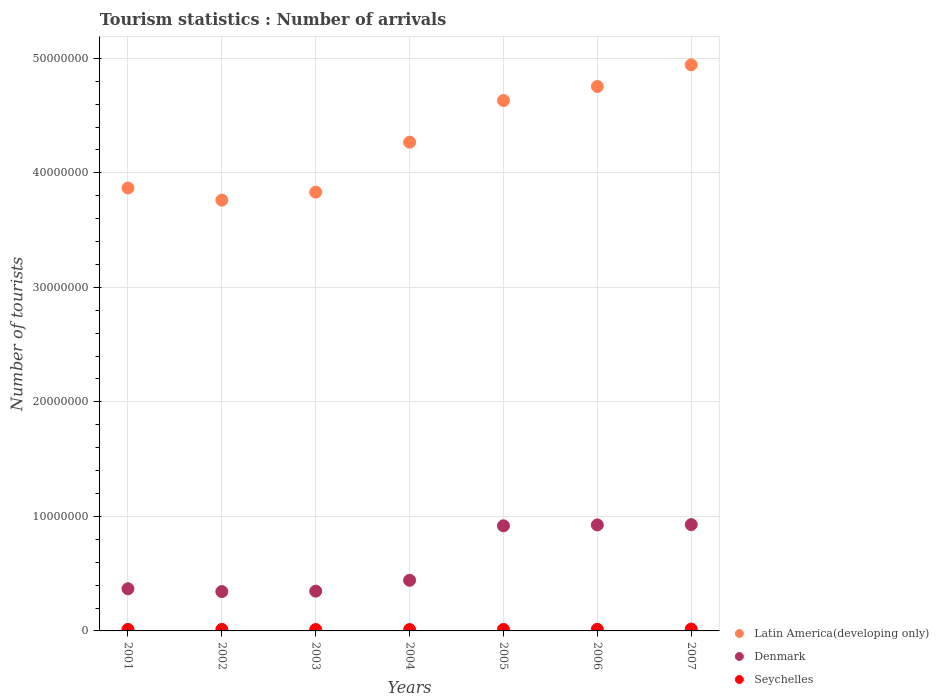How many different coloured dotlines are there?
Your answer should be compact. 3. What is the number of tourist arrivals in Seychelles in 2002?
Give a very brief answer. 1.32e+05. Across all years, what is the maximum number of tourist arrivals in Denmark?
Keep it short and to the point. 9.28e+06. Across all years, what is the minimum number of tourist arrivals in Latin America(developing only)?
Offer a terse response. 3.76e+07. In which year was the number of tourist arrivals in Seychelles maximum?
Offer a terse response. 2007. In which year was the number of tourist arrivals in Denmark minimum?
Keep it short and to the point. 2002. What is the total number of tourist arrivals in Denmark in the graph?
Give a very brief answer. 4.27e+07. What is the difference between the number of tourist arrivals in Latin America(developing only) in 2005 and that in 2007?
Offer a very short reply. -3.12e+06. What is the difference between the number of tourist arrivals in Seychelles in 2006 and the number of tourist arrivals in Latin America(developing only) in 2001?
Your response must be concise. -3.85e+07. What is the average number of tourist arrivals in Seychelles per year?
Offer a terse response. 1.34e+05. In the year 2002, what is the difference between the number of tourist arrivals in Latin America(developing only) and number of tourist arrivals in Denmark?
Your response must be concise. 3.42e+07. What is the ratio of the number of tourist arrivals in Denmark in 2001 to that in 2005?
Make the answer very short. 0.4. What is the difference between the highest and the second highest number of tourist arrivals in Latin America(developing only)?
Keep it short and to the point. 1.89e+06. What is the difference between the highest and the lowest number of tourist arrivals in Latin America(developing only)?
Provide a succinct answer. 1.18e+07. In how many years, is the number of tourist arrivals in Seychelles greater than the average number of tourist arrivals in Seychelles taken over all years?
Provide a succinct answer. 2. Is it the case that in every year, the sum of the number of tourist arrivals in Seychelles and number of tourist arrivals in Latin America(developing only)  is greater than the number of tourist arrivals in Denmark?
Your response must be concise. Yes. Is the number of tourist arrivals in Seychelles strictly less than the number of tourist arrivals in Latin America(developing only) over the years?
Offer a terse response. Yes. What is the title of the graph?
Ensure brevity in your answer.  Tourism statistics : Number of arrivals. What is the label or title of the X-axis?
Make the answer very short. Years. What is the label or title of the Y-axis?
Give a very brief answer. Number of tourists. What is the Number of tourists in Latin America(developing only) in 2001?
Offer a very short reply. 3.87e+07. What is the Number of tourists of Denmark in 2001?
Provide a succinct answer. 3.68e+06. What is the Number of tourists of Latin America(developing only) in 2002?
Offer a very short reply. 3.76e+07. What is the Number of tourists of Denmark in 2002?
Your answer should be very brief. 3.44e+06. What is the Number of tourists in Seychelles in 2002?
Your response must be concise. 1.32e+05. What is the Number of tourists in Latin America(developing only) in 2003?
Give a very brief answer. 3.83e+07. What is the Number of tourists of Denmark in 2003?
Offer a very short reply. 3.47e+06. What is the Number of tourists in Seychelles in 2003?
Your answer should be compact. 1.22e+05. What is the Number of tourists in Latin America(developing only) in 2004?
Offer a very short reply. 4.27e+07. What is the Number of tourists in Denmark in 2004?
Keep it short and to the point. 4.42e+06. What is the Number of tourists of Seychelles in 2004?
Your answer should be compact. 1.21e+05. What is the Number of tourists of Latin America(developing only) in 2005?
Your response must be concise. 4.63e+07. What is the Number of tourists in Denmark in 2005?
Ensure brevity in your answer.  9.18e+06. What is the Number of tourists of Seychelles in 2005?
Offer a terse response. 1.29e+05. What is the Number of tourists of Latin America(developing only) in 2006?
Provide a succinct answer. 4.75e+07. What is the Number of tourists in Denmark in 2006?
Offer a terse response. 9.26e+06. What is the Number of tourists in Seychelles in 2006?
Provide a succinct answer. 1.41e+05. What is the Number of tourists of Latin America(developing only) in 2007?
Your answer should be very brief. 4.94e+07. What is the Number of tourists in Denmark in 2007?
Your answer should be very brief. 9.28e+06. What is the Number of tourists in Seychelles in 2007?
Provide a short and direct response. 1.61e+05. Across all years, what is the maximum Number of tourists in Latin America(developing only)?
Your response must be concise. 4.94e+07. Across all years, what is the maximum Number of tourists in Denmark?
Offer a terse response. 9.28e+06. Across all years, what is the maximum Number of tourists of Seychelles?
Offer a very short reply. 1.61e+05. Across all years, what is the minimum Number of tourists in Latin America(developing only)?
Your answer should be very brief. 3.76e+07. Across all years, what is the minimum Number of tourists in Denmark?
Your response must be concise. 3.44e+06. Across all years, what is the minimum Number of tourists in Seychelles?
Ensure brevity in your answer.  1.21e+05. What is the total Number of tourists of Latin America(developing only) in the graph?
Make the answer very short. 3.01e+08. What is the total Number of tourists of Denmark in the graph?
Provide a short and direct response. 4.27e+07. What is the total Number of tourists in Seychelles in the graph?
Offer a terse response. 9.36e+05. What is the difference between the Number of tourists in Latin America(developing only) in 2001 and that in 2002?
Offer a terse response. 1.06e+06. What is the difference between the Number of tourists in Denmark in 2001 and that in 2002?
Your answer should be compact. 2.48e+05. What is the difference between the Number of tourists of Seychelles in 2001 and that in 2002?
Your response must be concise. -2000. What is the difference between the Number of tourists in Latin America(developing only) in 2001 and that in 2003?
Provide a succinct answer. 3.61e+05. What is the difference between the Number of tourists in Seychelles in 2001 and that in 2003?
Provide a succinct answer. 8000. What is the difference between the Number of tourists in Latin America(developing only) in 2001 and that in 2004?
Offer a terse response. -4.00e+06. What is the difference between the Number of tourists in Denmark in 2001 and that in 2004?
Your response must be concise. -7.37e+05. What is the difference between the Number of tourists of Seychelles in 2001 and that in 2004?
Keep it short and to the point. 9000. What is the difference between the Number of tourists of Latin America(developing only) in 2001 and that in 2005?
Offer a very short reply. -7.64e+06. What is the difference between the Number of tourists in Denmark in 2001 and that in 2005?
Provide a succinct answer. -5.49e+06. What is the difference between the Number of tourists of Latin America(developing only) in 2001 and that in 2006?
Offer a terse response. -8.86e+06. What is the difference between the Number of tourists in Denmark in 2001 and that in 2006?
Make the answer very short. -5.57e+06. What is the difference between the Number of tourists in Seychelles in 2001 and that in 2006?
Your answer should be very brief. -1.10e+04. What is the difference between the Number of tourists in Latin America(developing only) in 2001 and that in 2007?
Provide a succinct answer. -1.08e+07. What is the difference between the Number of tourists of Denmark in 2001 and that in 2007?
Give a very brief answer. -5.60e+06. What is the difference between the Number of tourists in Seychelles in 2001 and that in 2007?
Your answer should be compact. -3.10e+04. What is the difference between the Number of tourists in Latin America(developing only) in 2002 and that in 2003?
Provide a short and direct response. -7.00e+05. What is the difference between the Number of tourists of Denmark in 2002 and that in 2003?
Make the answer very short. -3.80e+04. What is the difference between the Number of tourists in Latin America(developing only) in 2002 and that in 2004?
Give a very brief answer. -5.06e+06. What is the difference between the Number of tourists in Denmark in 2002 and that in 2004?
Ensure brevity in your answer.  -9.85e+05. What is the difference between the Number of tourists of Seychelles in 2002 and that in 2004?
Your answer should be compact. 1.10e+04. What is the difference between the Number of tourists in Latin America(developing only) in 2002 and that in 2005?
Ensure brevity in your answer.  -8.70e+06. What is the difference between the Number of tourists in Denmark in 2002 and that in 2005?
Provide a short and direct response. -5.74e+06. What is the difference between the Number of tourists of Seychelles in 2002 and that in 2005?
Offer a very short reply. 3000. What is the difference between the Number of tourists of Latin America(developing only) in 2002 and that in 2006?
Your answer should be compact. -9.93e+06. What is the difference between the Number of tourists of Denmark in 2002 and that in 2006?
Offer a very short reply. -5.82e+06. What is the difference between the Number of tourists in Seychelles in 2002 and that in 2006?
Your answer should be very brief. -9000. What is the difference between the Number of tourists in Latin America(developing only) in 2002 and that in 2007?
Your response must be concise. -1.18e+07. What is the difference between the Number of tourists in Denmark in 2002 and that in 2007?
Ensure brevity in your answer.  -5.85e+06. What is the difference between the Number of tourists in Seychelles in 2002 and that in 2007?
Your answer should be compact. -2.90e+04. What is the difference between the Number of tourists in Latin America(developing only) in 2003 and that in 2004?
Your answer should be compact. -4.36e+06. What is the difference between the Number of tourists in Denmark in 2003 and that in 2004?
Provide a short and direct response. -9.47e+05. What is the difference between the Number of tourists in Latin America(developing only) in 2003 and that in 2005?
Your response must be concise. -8.00e+06. What is the difference between the Number of tourists of Denmark in 2003 and that in 2005?
Provide a succinct answer. -5.70e+06. What is the difference between the Number of tourists of Seychelles in 2003 and that in 2005?
Provide a succinct answer. -7000. What is the difference between the Number of tourists of Latin America(developing only) in 2003 and that in 2006?
Your answer should be compact. -9.23e+06. What is the difference between the Number of tourists in Denmark in 2003 and that in 2006?
Provide a short and direct response. -5.78e+06. What is the difference between the Number of tourists in Seychelles in 2003 and that in 2006?
Your response must be concise. -1.90e+04. What is the difference between the Number of tourists in Latin America(developing only) in 2003 and that in 2007?
Ensure brevity in your answer.  -1.11e+07. What is the difference between the Number of tourists of Denmark in 2003 and that in 2007?
Keep it short and to the point. -5.81e+06. What is the difference between the Number of tourists in Seychelles in 2003 and that in 2007?
Make the answer very short. -3.90e+04. What is the difference between the Number of tourists in Latin America(developing only) in 2004 and that in 2005?
Provide a short and direct response. -3.63e+06. What is the difference between the Number of tourists of Denmark in 2004 and that in 2005?
Provide a succinct answer. -4.76e+06. What is the difference between the Number of tourists in Seychelles in 2004 and that in 2005?
Offer a terse response. -8000. What is the difference between the Number of tourists in Latin America(developing only) in 2004 and that in 2006?
Offer a terse response. -4.86e+06. What is the difference between the Number of tourists in Denmark in 2004 and that in 2006?
Make the answer very short. -4.84e+06. What is the difference between the Number of tourists of Seychelles in 2004 and that in 2006?
Your answer should be compact. -2.00e+04. What is the difference between the Number of tourists of Latin America(developing only) in 2004 and that in 2007?
Offer a very short reply. -6.75e+06. What is the difference between the Number of tourists of Denmark in 2004 and that in 2007?
Make the answer very short. -4.86e+06. What is the difference between the Number of tourists in Latin America(developing only) in 2005 and that in 2006?
Your answer should be very brief. -1.23e+06. What is the difference between the Number of tourists in Denmark in 2005 and that in 2006?
Keep it short and to the point. -7.80e+04. What is the difference between the Number of tourists in Seychelles in 2005 and that in 2006?
Provide a succinct answer. -1.20e+04. What is the difference between the Number of tourists in Latin America(developing only) in 2005 and that in 2007?
Make the answer very short. -3.12e+06. What is the difference between the Number of tourists in Denmark in 2005 and that in 2007?
Give a very brief answer. -1.06e+05. What is the difference between the Number of tourists of Seychelles in 2005 and that in 2007?
Provide a short and direct response. -3.20e+04. What is the difference between the Number of tourists in Latin America(developing only) in 2006 and that in 2007?
Provide a short and direct response. -1.89e+06. What is the difference between the Number of tourists of Denmark in 2006 and that in 2007?
Keep it short and to the point. -2.80e+04. What is the difference between the Number of tourists in Latin America(developing only) in 2001 and the Number of tourists in Denmark in 2002?
Keep it short and to the point. 3.52e+07. What is the difference between the Number of tourists in Latin America(developing only) in 2001 and the Number of tourists in Seychelles in 2002?
Your answer should be compact. 3.85e+07. What is the difference between the Number of tourists in Denmark in 2001 and the Number of tourists in Seychelles in 2002?
Your answer should be compact. 3.55e+06. What is the difference between the Number of tourists of Latin America(developing only) in 2001 and the Number of tourists of Denmark in 2003?
Give a very brief answer. 3.52e+07. What is the difference between the Number of tourists of Latin America(developing only) in 2001 and the Number of tourists of Seychelles in 2003?
Make the answer very short. 3.86e+07. What is the difference between the Number of tourists of Denmark in 2001 and the Number of tourists of Seychelles in 2003?
Your answer should be very brief. 3.56e+06. What is the difference between the Number of tourists of Latin America(developing only) in 2001 and the Number of tourists of Denmark in 2004?
Your answer should be very brief. 3.43e+07. What is the difference between the Number of tourists of Latin America(developing only) in 2001 and the Number of tourists of Seychelles in 2004?
Ensure brevity in your answer.  3.86e+07. What is the difference between the Number of tourists in Denmark in 2001 and the Number of tourists in Seychelles in 2004?
Your answer should be compact. 3.56e+06. What is the difference between the Number of tourists of Latin America(developing only) in 2001 and the Number of tourists of Denmark in 2005?
Give a very brief answer. 2.95e+07. What is the difference between the Number of tourists of Latin America(developing only) in 2001 and the Number of tourists of Seychelles in 2005?
Make the answer very short. 3.85e+07. What is the difference between the Number of tourists in Denmark in 2001 and the Number of tourists in Seychelles in 2005?
Provide a short and direct response. 3.56e+06. What is the difference between the Number of tourists in Latin America(developing only) in 2001 and the Number of tourists in Denmark in 2006?
Offer a very short reply. 2.94e+07. What is the difference between the Number of tourists in Latin America(developing only) in 2001 and the Number of tourists in Seychelles in 2006?
Give a very brief answer. 3.85e+07. What is the difference between the Number of tourists of Denmark in 2001 and the Number of tourists of Seychelles in 2006?
Offer a very short reply. 3.54e+06. What is the difference between the Number of tourists of Latin America(developing only) in 2001 and the Number of tourists of Denmark in 2007?
Your answer should be very brief. 2.94e+07. What is the difference between the Number of tourists of Latin America(developing only) in 2001 and the Number of tourists of Seychelles in 2007?
Make the answer very short. 3.85e+07. What is the difference between the Number of tourists of Denmark in 2001 and the Number of tourists of Seychelles in 2007?
Your answer should be very brief. 3.52e+06. What is the difference between the Number of tourists in Latin America(developing only) in 2002 and the Number of tourists in Denmark in 2003?
Keep it short and to the point. 3.41e+07. What is the difference between the Number of tourists in Latin America(developing only) in 2002 and the Number of tourists in Seychelles in 2003?
Make the answer very short. 3.75e+07. What is the difference between the Number of tourists in Denmark in 2002 and the Number of tourists in Seychelles in 2003?
Your response must be concise. 3.31e+06. What is the difference between the Number of tourists in Latin America(developing only) in 2002 and the Number of tourists in Denmark in 2004?
Provide a succinct answer. 3.32e+07. What is the difference between the Number of tourists of Latin America(developing only) in 2002 and the Number of tourists of Seychelles in 2004?
Your response must be concise. 3.75e+07. What is the difference between the Number of tourists in Denmark in 2002 and the Number of tourists in Seychelles in 2004?
Ensure brevity in your answer.  3.32e+06. What is the difference between the Number of tourists of Latin America(developing only) in 2002 and the Number of tourists of Denmark in 2005?
Your answer should be compact. 2.84e+07. What is the difference between the Number of tourists in Latin America(developing only) in 2002 and the Number of tourists in Seychelles in 2005?
Keep it short and to the point. 3.75e+07. What is the difference between the Number of tourists in Denmark in 2002 and the Number of tourists in Seychelles in 2005?
Your answer should be compact. 3.31e+06. What is the difference between the Number of tourists in Latin America(developing only) in 2002 and the Number of tourists in Denmark in 2006?
Give a very brief answer. 2.84e+07. What is the difference between the Number of tourists of Latin America(developing only) in 2002 and the Number of tourists of Seychelles in 2006?
Provide a short and direct response. 3.75e+07. What is the difference between the Number of tourists in Denmark in 2002 and the Number of tourists in Seychelles in 2006?
Give a very brief answer. 3.30e+06. What is the difference between the Number of tourists of Latin America(developing only) in 2002 and the Number of tourists of Denmark in 2007?
Keep it short and to the point. 2.83e+07. What is the difference between the Number of tourists in Latin America(developing only) in 2002 and the Number of tourists in Seychelles in 2007?
Offer a very short reply. 3.75e+07. What is the difference between the Number of tourists of Denmark in 2002 and the Number of tourists of Seychelles in 2007?
Your answer should be very brief. 3.28e+06. What is the difference between the Number of tourists of Latin America(developing only) in 2003 and the Number of tourists of Denmark in 2004?
Provide a short and direct response. 3.39e+07. What is the difference between the Number of tourists of Latin America(developing only) in 2003 and the Number of tourists of Seychelles in 2004?
Offer a terse response. 3.82e+07. What is the difference between the Number of tourists in Denmark in 2003 and the Number of tourists in Seychelles in 2004?
Offer a very short reply. 3.35e+06. What is the difference between the Number of tourists of Latin America(developing only) in 2003 and the Number of tourists of Denmark in 2005?
Give a very brief answer. 2.91e+07. What is the difference between the Number of tourists of Latin America(developing only) in 2003 and the Number of tourists of Seychelles in 2005?
Your answer should be very brief. 3.82e+07. What is the difference between the Number of tourists of Denmark in 2003 and the Number of tourists of Seychelles in 2005?
Keep it short and to the point. 3.34e+06. What is the difference between the Number of tourists of Latin America(developing only) in 2003 and the Number of tourists of Denmark in 2006?
Your answer should be very brief. 2.91e+07. What is the difference between the Number of tourists in Latin America(developing only) in 2003 and the Number of tourists in Seychelles in 2006?
Your answer should be very brief. 3.82e+07. What is the difference between the Number of tourists in Denmark in 2003 and the Number of tourists in Seychelles in 2006?
Make the answer very short. 3.33e+06. What is the difference between the Number of tourists of Latin America(developing only) in 2003 and the Number of tourists of Denmark in 2007?
Your answer should be very brief. 2.90e+07. What is the difference between the Number of tourists of Latin America(developing only) in 2003 and the Number of tourists of Seychelles in 2007?
Offer a very short reply. 3.82e+07. What is the difference between the Number of tourists in Denmark in 2003 and the Number of tourists in Seychelles in 2007?
Your answer should be very brief. 3.31e+06. What is the difference between the Number of tourists of Latin America(developing only) in 2004 and the Number of tourists of Denmark in 2005?
Provide a short and direct response. 3.35e+07. What is the difference between the Number of tourists in Latin America(developing only) in 2004 and the Number of tourists in Seychelles in 2005?
Make the answer very short. 4.25e+07. What is the difference between the Number of tourists in Denmark in 2004 and the Number of tourists in Seychelles in 2005?
Make the answer very short. 4.29e+06. What is the difference between the Number of tourists of Latin America(developing only) in 2004 and the Number of tourists of Denmark in 2006?
Provide a short and direct response. 3.34e+07. What is the difference between the Number of tourists of Latin America(developing only) in 2004 and the Number of tourists of Seychelles in 2006?
Your response must be concise. 4.25e+07. What is the difference between the Number of tourists in Denmark in 2004 and the Number of tourists in Seychelles in 2006?
Provide a succinct answer. 4.28e+06. What is the difference between the Number of tourists of Latin America(developing only) in 2004 and the Number of tourists of Denmark in 2007?
Your answer should be very brief. 3.34e+07. What is the difference between the Number of tourists in Latin America(developing only) in 2004 and the Number of tourists in Seychelles in 2007?
Give a very brief answer. 4.25e+07. What is the difference between the Number of tourists of Denmark in 2004 and the Number of tourists of Seychelles in 2007?
Provide a succinct answer. 4.26e+06. What is the difference between the Number of tourists of Latin America(developing only) in 2005 and the Number of tourists of Denmark in 2006?
Offer a terse response. 3.71e+07. What is the difference between the Number of tourists in Latin America(developing only) in 2005 and the Number of tourists in Seychelles in 2006?
Keep it short and to the point. 4.62e+07. What is the difference between the Number of tourists of Denmark in 2005 and the Number of tourists of Seychelles in 2006?
Provide a succinct answer. 9.04e+06. What is the difference between the Number of tourists of Latin America(developing only) in 2005 and the Number of tourists of Denmark in 2007?
Offer a very short reply. 3.70e+07. What is the difference between the Number of tourists of Latin America(developing only) in 2005 and the Number of tourists of Seychelles in 2007?
Your answer should be very brief. 4.62e+07. What is the difference between the Number of tourists of Denmark in 2005 and the Number of tourists of Seychelles in 2007?
Your answer should be very brief. 9.02e+06. What is the difference between the Number of tourists in Latin America(developing only) in 2006 and the Number of tourists in Denmark in 2007?
Provide a succinct answer. 3.83e+07. What is the difference between the Number of tourists in Latin America(developing only) in 2006 and the Number of tourists in Seychelles in 2007?
Make the answer very short. 4.74e+07. What is the difference between the Number of tourists in Denmark in 2006 and the Number of tourists in Seychelles in 2007?
Give a very brief answer. 9.10e+06. What is the average Number of tourists of Latin America(developing only) per year?
Your response must be concise. 4.29e+07. What is the average Number of tourists in Denmark per year?
Your answer should be compact. 6.10e+06. What is the average Number of tourists of Seychelles per year?
Make the answer very short. 1.34e+05. In the year 2001, what is the difference between the Number of tourists in Latin America(developing only) and Number of tourists in Denmark?
Your answer should be compact. 3.50e+07. In the year 2001, what is the difference between the Number of tourists of Latin America(developing only) and Number of tourists of Seychelles?
Your answer should be very brief. 3.85e+07. In the year 2001, what is the difference between the Number of tourists of Denmark and Number of tourists of Seychelles?
Your answer should be very brief. 3.55e+06. In the year 2002, what is the difference between the Number of tourists of Latin America(developing only) and Number of tourists of Denmark?
Your answer should be compact. 3.42e+07. In the year 2002, what is the difference between the Number of tourists in Latin America(developing only) and Number of tourists in Seychelles?
Provide a succinct answer. 3.75e+07. In the year 2002, what is the difference between the Number of tourists of Denmark and Number of tourists of Seychelles?
Offer a terse response. 3.30e+06. In the year 2003, what is the difference between the Number of tourists of Latin America(developing only) and Number of tourists of Denmark?
Provide a short and direct response. 3.48e+07. In the year 2003, what is the difference between the Number of tourists in Latin America(developing only) and Number of tourists in Seychelles?
Give a very brief answer. 3.82e+07. In the year 2003, what is the difference between the Number of tourists of Denmark and Number of tourists of Seychelles?
Make the answer very short. 3.35e+06. In the year 2004, what is the difference between the Number of tourists of Latin America(developing only) and Number of tourists of Denmark?
Your answer should be very brief. 3.83e+07. In the year 2004, what is the difference between the Number of tourists of Latin America(developing only) and Number of tourists of Seychelles?
Provide a succinct answer. 4.26e+07. In the year 2004, what is the difference between the Number of tourists in Denmark and Number of tourists in Seychelles?
Provide a short and direct response. 4.30e+06. In the year 2005, what is the difference between the Number of tourists of Latin America(developing only) and Number of tourists of Denmark?
Give a very brief answer. 3.71e+07. In the year 2005, what is the difference between the Number of tourists in Latin America(developing only) and Number of tourists in Seychelles?
Provide a succinct answer. 4.62e+07. In the year 2005, what is the difference between the Number of tourists in Denmark and Number of tourists in Seychelles?
Give a very brief answer. 9.05e+06. In the year 2006, what is the difference between the Number of tourists of Latin America(developing only) and Number of tourists of Denmark?
Your answer should be very brief. 3.83e+07. In the year 2006, what is the difference between the Number of tourists in Latin America(developing only) and Number of tourists in Seychelles?
Ensure brevity in your answer.  4.74e+07. In the year 2006, what is the difference between the Number of tourists of Denmark and Number of tourists of Seychelles?
Make the answer very short. 9.12e+06. In the year 2007, what is the difference between the Number of tourists of Latin America(developing only) and Number of tourists of Denmark?
Offer a terse response. 4.01e+07. In the year 2007, what is the difference between the Number of tourists in Latin America(developing only) and Number of tourists in Seychelles?
Keep it short and to the point. 4.93e+07. In the year 2007, what is the difference between the Number of tourists in Denmark and Number of tourists in Seychelles?
Your answer should be compact. 9.12e+06. What is the ratio of the Number of tourists of Latin America(developing only) in 2001 to that in 2002?
Provide a succinct answer. 1.03. What is the ratio of the Number of tourists in Denmark in 2001 to that in 2002?
Your answer should be compact. 1.07. What is the ratio of the Number of tourists in Seychelles in 2001 to that in 2002?
Provide a succinct answer. 0.98. What is the ratio of the Number of tourists of Latin America(developing only) in 2001 to that in 2003?
Your answer should be compact. 1.01. What is the ratio of the Number of tourists of Denmark in 2001 to that in 2003?
Keep it short and to the point. 1.06. What is the ratio of the Number of tourists in Seychelles in 2001 to that in 2003?
Provide a succinct answer. 1.07. What is the ratio of the Number of tourists of Latin America(developing only) in 2001 to that in 2004?
Ensure brevity in your answer.  0.91. What is the ratio of the Number of tourists of Seychelles in 2001 to that in 2004?
Your response must be concise. 1.07. What is the ratio of the Number of tourists of Latin America(developing only) in 2001 to that in 2005?
Ensure brevity in your answer.  0.84. What is the ratio of the Number of tourists in Denmark in 2001 to that in 2005?
Make the answer very short. 0.4. What is the ratio of the Number of tourists in Latin America(developing only) in 2001 to that in 2006?
Your answer should be very brief. 0.81. What is the ratio of the Number of tourists in Denmark in 2001 to that in 2006?
Offer a terse response. 0.4. What is the ratio of the Number of tourists in Seychelles in 2001 to that in 2006?
Make the answer very short. 0.92. What is the ratio of the Number of tourists of Latin America(developing only) in 2001 to that in 2007?
Your answer should be compact. 0.78. What is the ratio of the Number of tourists in Denmark in 2001 to that in 2007?
Provide a short and direct response. 0.4. What is the ratio of the Number of tourists in Seychelles in 2001 to that in 2007?
Offer a terse response. 0.81. What is the ratio of the Number of tourists in Latin America(developing only) in 2002 to that in 2003?
Provide a short and direct response. 0.98. What is the ratio of the Number of tourists in Seychelles in 2002 to that in 2003?
Give a very brief answer. 1.08. What is the ratio of the Number of tourists in Latin America(developing only) in 2002 to that in 2004?
Provide a succinct answer. 0.88. What is the ratio of the Number of tourists in Denmark in 2002 to that in 2004?
Offer a very short reply. 0.78. What is the ratio of the Number of tourists of Seychelles in 2002 to that in 2004?
Give a very brief answer. 1.09. What is the ratio of the Number of tourists of Latin America(developing only) in 2002 to that in 2005?
Keep it short and to the point. 0.81. What is the ratio of the Number of tourists in Denmark in 2002 to that in 2005?
Offer a terse response. 0.37. What is the ratio of the Number of tourists in Seychelles in 2002 to that in 2005?
Provide a short and direct response. 1.02. What is the ratio of the Number of tourists of Latin America(developing only) in 2002 to that in 2006?
Provide a short and direct response. 0.79. What is the ratio of the Number of tourists in Denmark in 2002 to that in 2006?
Your response must be concise. 0.37. What is the ratio of the Number of tourists in Seychelles in 2002 to that in 2006?
Make the answer very short. 0.94. What is the ratio of the Number of tourists in Latin America(developing only) in 2002 to that in 2007?
Your answer should be very brief. 0.76. What is the ratio of the Number of tourists of Denmark in 2002 to that in 2007?
Ensure brevity in your answer.  0.37. What is the ratio of the Number of tourists in Seychelles in 2002 to that in 2007?
Your answer should be compact. 0.82. What is the ratio of the Number of tourists of Latin America(developing only) in 2003 to that in 2004?
Offer a very short reply. 0.9. What is the ratio of the Number of tourists in Denmark in 2003 to that in 2004?
Offer a terse response. 0.79. What is the ratio of the Number of tourists of Seychelles in 2003 to that in 2004?
Your response must be concise. 1.01. What is the ratio of the Number of tourists of Latin America(developing only) in 2003 to that in 2005?
Offer a terse response. 0.83. What is the ratio of the Number of tourists of Denmark in 2003 to that in 2005?
Offer a very short reply. 0.38. What is the ratio of the Number of tourists of Seychelles in 2003 to that in 2005?
Ensure brevity in your answer.  0.95. What is the ratio of the Number of tourists in Latin America(developing only) in 2003 to that in 2006?
Offer a very short reply. 0.81. What is the ratio of the Number of tourists in Denmark in 2003 to that in 2006?
Your answer should be compact. 0.38. What is the ratio of the Number of tourists of Seychelles in 2003 to that in 2006?
Your answer should be very brief. 0.87. What is the ratio of the Number of tourists in Latin America(developing only) in 2003 to that in 2007?
Provide a succinct answer. 0.78. What is the ratio of the Number of tourists in Denmark in 2003 to that in 2007?
Your answer should be very brief. 0.37. What is the ratio of the Number of tourists in Seychelles in 2003 to that in 2007?
Keep it short and to the point. 0.76. What is the ratio of the Number of tourists of Latin America(developing only) in 2004 to that in 2005?
Your answer should be compact. 0.92. What is the ratio of the Number of tourists in Denmark in 2004 to that in 2005?
Your answer should be very brief. 0.48. What is the ratio of the Number of tourists in Seychelles in 2004 to that in 2005?
Provide a succinct answer. 0.94. What is the ratio of the Number of tourists in Latin America(developing only) in 2004 to that in 2006?
Provide a succinct answer. 0.9. What is the ratio of the Number of tourists in Denmark in 2004 to that in 2006?
Your response must be concise. 0.48. What is the ratio of the Number of tourists in Seychelles in 2004 to that in 2006?
Your answer should be very brief. 0.86. What is the ratio of the Number of tourists of Latin America(developing only) in 2004 to that in 2007?
Give a very brief answer. 0.86. What is the ratio of the Number of tourists of Denmark in 2004 to that in 2007?
Provide a succinct answer. 0.48. What is the ratio of the Number of tourists in Seychelles in 2004 to that in 2007?
Provide a succinct answer. 0.75. What is the ratio of the Number of tourists of Latin America(developing only) in 2005 to that in 2006?
Provide a succinct answer. 0.97. What is the ratio of the Number of tourists in Seychelles in 2005 to that in 2006?
Your response must be concise. 0.91. What is the ratio of the Number of tourists of Latin America(developing only) in 2005 to that in 2007?
Give a very brief answer. 0.94. What is the ratio of the Number of tourists in Denmark in 2005 to that in 2007?
Your answer should be very brief. 0.99. What is the ratio of the Number of tourists of Seychelles in 2005 to that in 2007?
Offer a terse response. 0.8. What is the ratio of the Number of tourists of Latin America(developing only) in 2006 to that in 2007?
Offer a terse response. 0.96. What is the ratio of the Number of tourists in Denmark in 2006 to that in 2007?
Offer a terse response. 1. What is the ratio of the Number of tourists in Seychelles in 2006 to that in 2007?
Your answer should be compact. 0.88. What is the difference between the highest and the second highest Number of tourists in Latin America(developing only)?
Provide a short and direct response. 1.89e+06. What is the difference between the highest and the second highest Number of tourists in Denmark?
Your response must be concise. 2.80e+04. What is the difference between the highest and the second highest Number of tourists of Seychelles?
Keep it short and to the point. 2.00e+04. What is the difference between the highest and the lowest Number of tourists in Latin America(developing only)?
Provide a short and direct response. 1.18e+07. What is the difference between the highest and the lowest Number of tourists in Denmark?
Ensure brevity in your answer.  5.85e+06. What is the difference between the highest and the lowest Number of tourists in Seychelles?
Make the answer very short. 4.00e+04. 